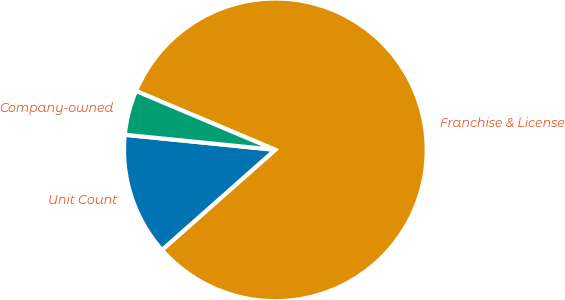<chart> <loc_0><loc_0><loc_500><loc_500><pie_chart><fcel>Unit Count<fcel>Franchise & License<fcel>Company-owned<nl><fcel>13.12%<fcel>82.11%<fcel>4.77%<nl></chart> 